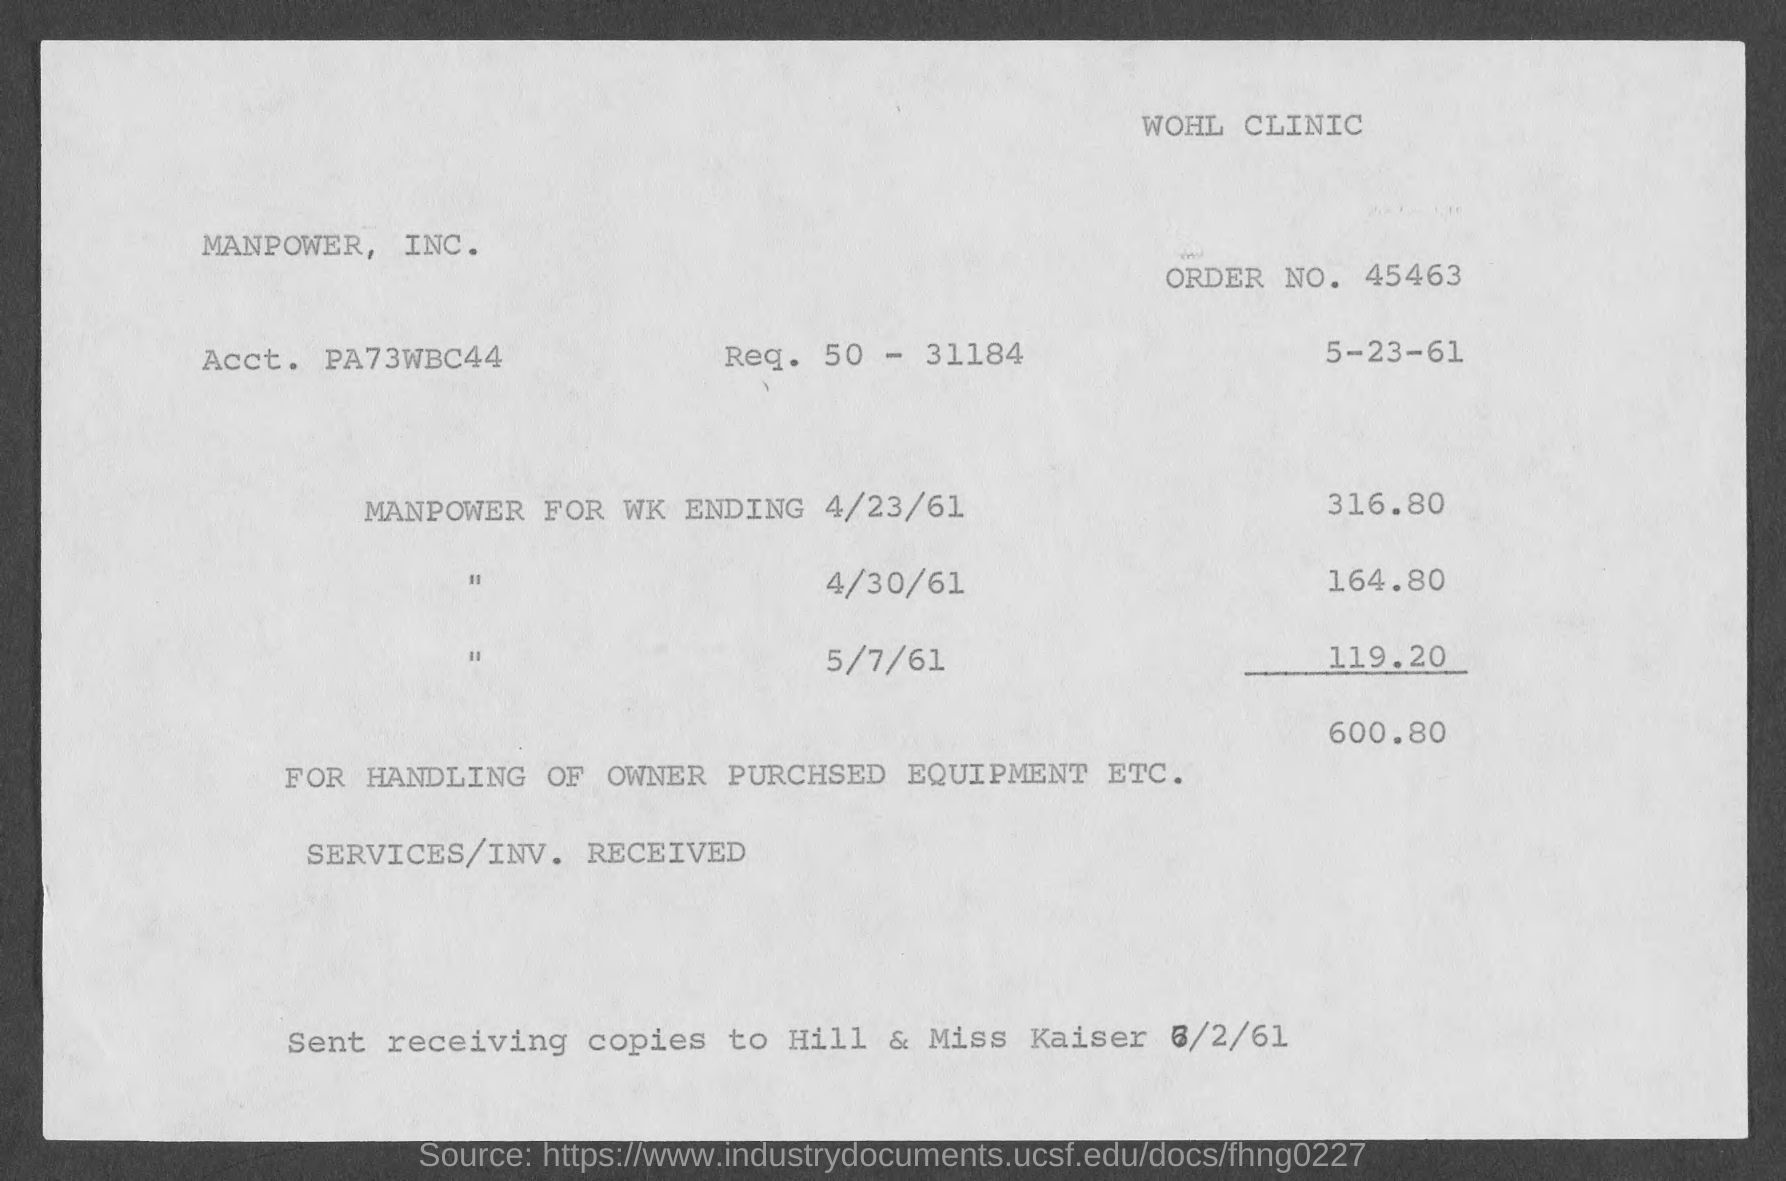What is the order no.?
Your response must be concise. 45463. What is the acct. no. ?
Your response must be concise. PA73WBC44. 